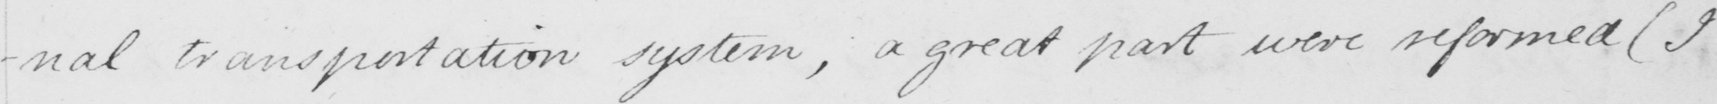Can you read and transcribe this handwriting? -nal transportation system , a great part were reformed  ( I 